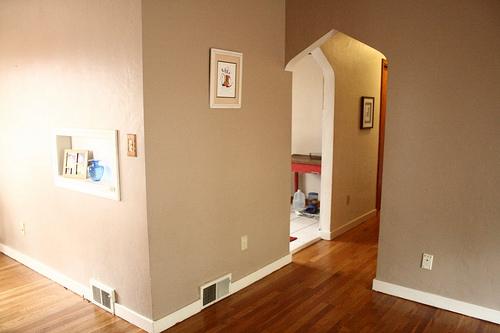What color are the walls?
Keep it brief. Beige. What color are the baseboards?
Be succinct. White. Is there any carpet on the floor?
Answer briefly. No. 